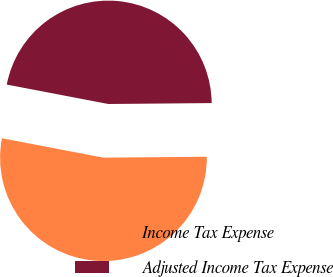<chart> <loc_0><loc_0><loc_500><loc_500><pie_chart><fcel>Income Tax Expense<fcel>Adjusted Income Tax Expense<nl><fcel>53.15%<fcel>46.85%<nl></chart> 